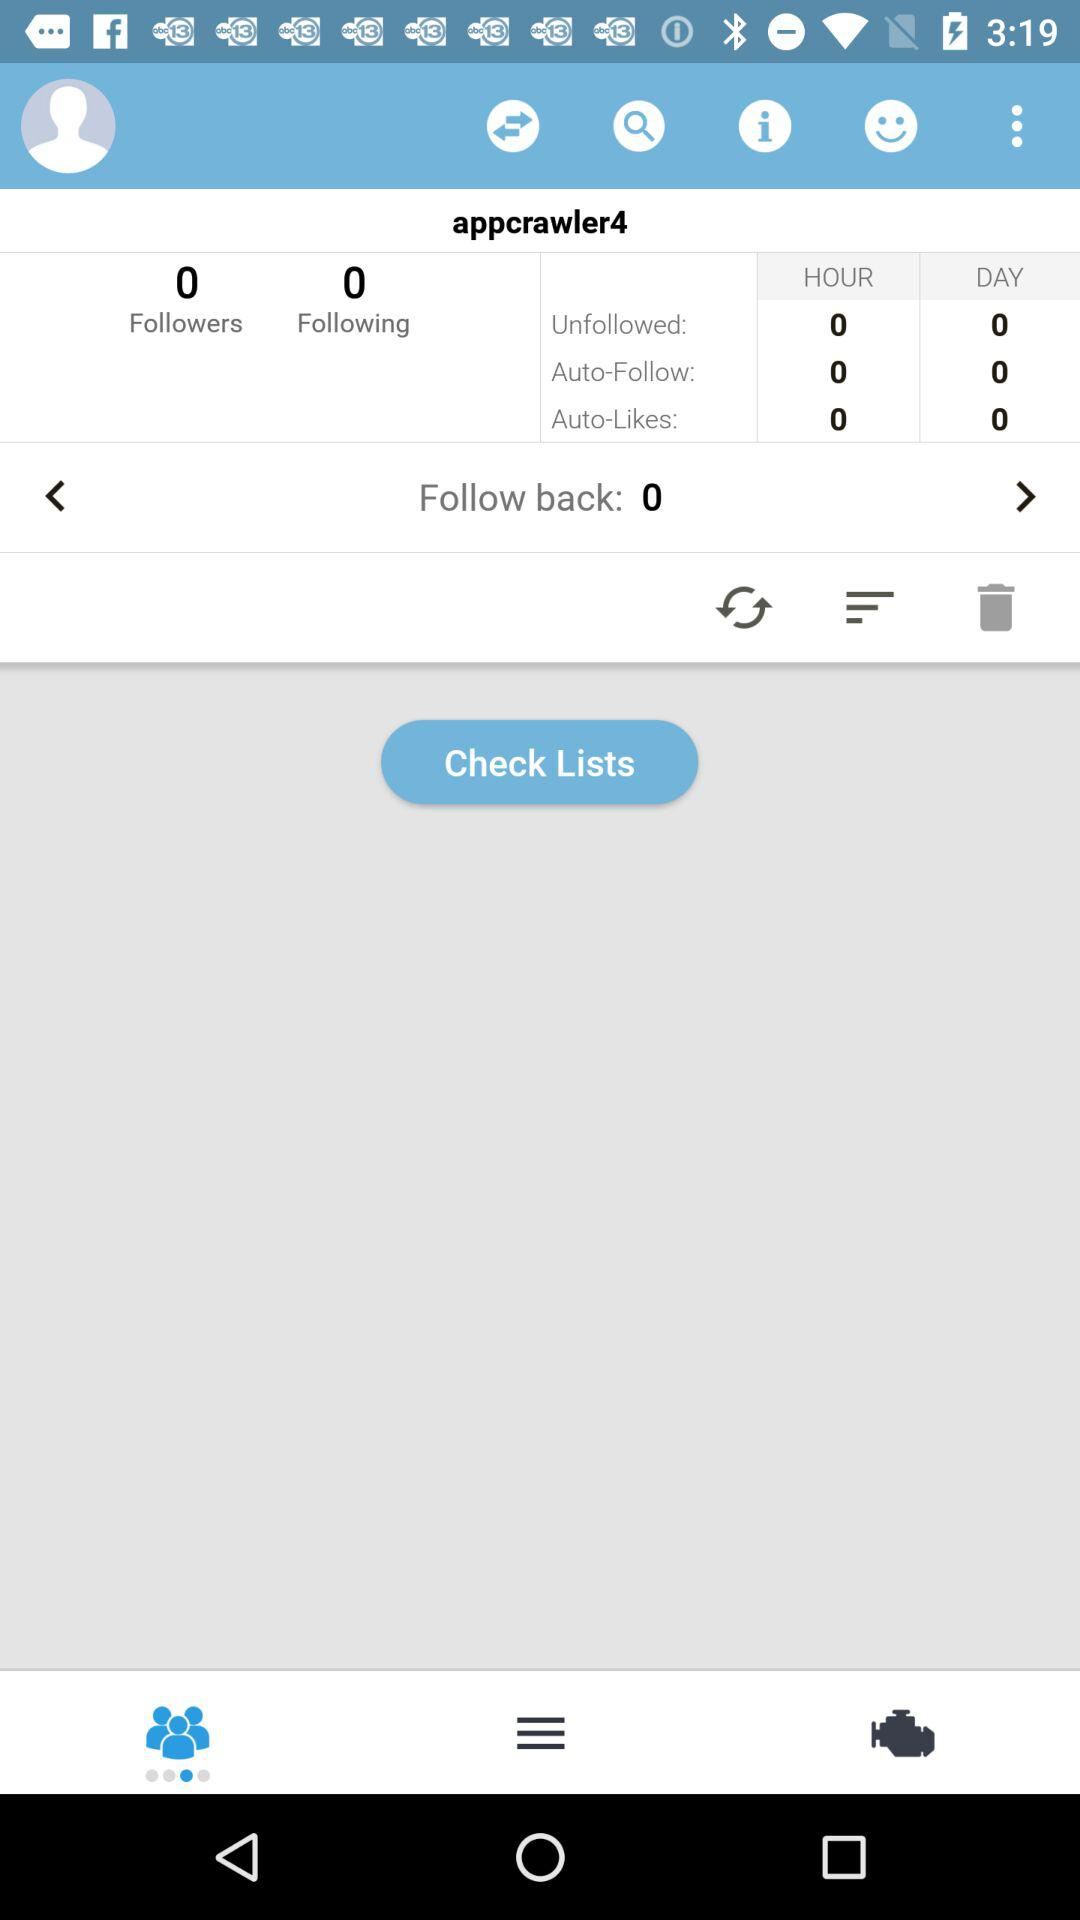What is the username? The username is "appcrawler4". 